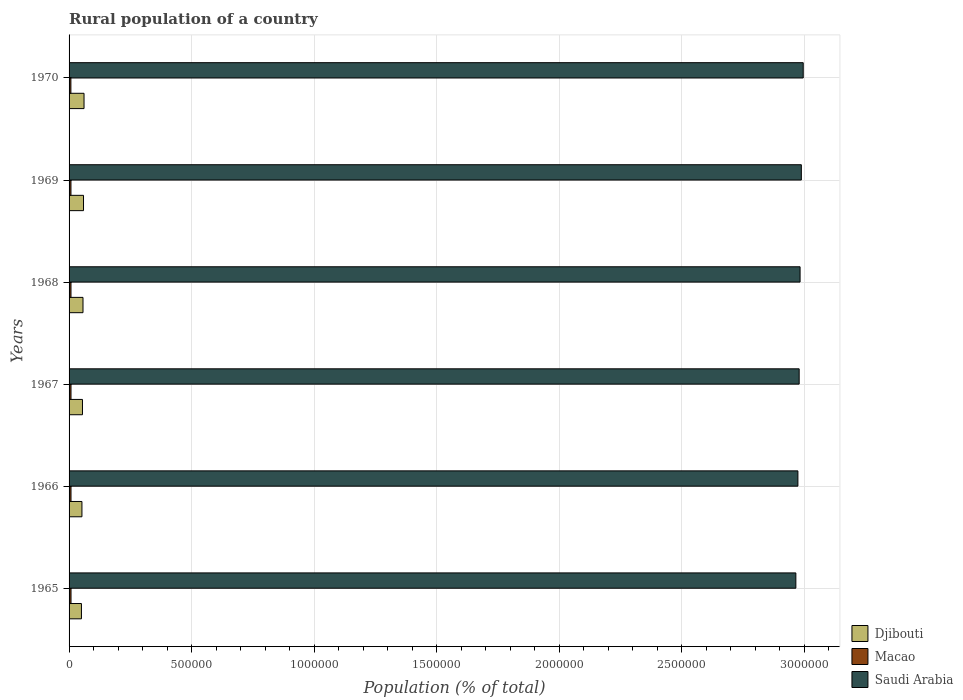How many different coloured bars are there?
Keep it short and to the point. 3. Are the number of bars per tick equal to the number of legend labels?
Keep it short and to the point. Yes. Are the number of bars on each tick of the Y-axis equal?
Make the answer very short. Yes. How many bars are there on the 4th tick from the top?
Give a very brief answer. 3. What is the label of the 4th group of bars from the top?
Give a very brief answer. 1967. What is the rural population in Djibouti in 1966?
Ensure brevity in your answer.  5.25e+04. Across all years, what is the maximum rural population in Saudi Arabia?
Your response must be concise. 3.00e+06. Across all years, what is the minimum rural population in Saudi Arabia?
Offer a very short reply. 2.97e+06. In which year was the rural population in Saudi Arabia minimum?
Keep it short and to the point. 1965. What is the total rural population in Macao in the graph?
Keep it short and to the point. 4.65e+04. What is the difference between the rural population in Djibouti in 1965 and that in 1968?
Your response must be concise. -6373. What is the difference between the rural population in Djibouti in 1966 and the rural population in Macao in 1968?
Offer a terse response. 4.47e+04. What is the average rural population in Macao per year?
Your answer should be compact. 7758. In the year 1965, what is the difference between the rural population in Saudi Arabia and rural population in Macao?
Your response must be concise. 2.96e+06. What is the ratio of the rural population in Saudi Arabia in 1966 to that in 1969?
Provide a succinct answer. 1. Is the rural population in Djibouti in 1965 less than that in 1970?
Your response must be concise. Yes. What is the difference between the highest and the second highest rural population in Saudi Arabia?
Your answer should be compact. 7679. What is the difference between the highest and the lowest rural population in Macao?
Provide a succinct answer. 460. In how many years, is the rural population in Macao greater than the average rural population in Macao taken over all years?
Provide a succinct answer. 4. What does the 1st bar from the top in 1969 represents?
Give a very brief answer. Saudi Arabia. What does the 2nd bar from the bottom in 1967 represents?
Provide a succinct answer. Macao. Are all the bars in the graph horizontal?
Provide a succinct answer. Yes. What is the difference between two consecutive major ticks on the X-axis?
Make the answer very short. 5.00e+05. How are the legend labels stacked?
Your answer should be very brief. Vertical. What is the title of the graph?
Offer a very short reply. Rural population of a country. Does "Sint Maarten (Dutch part)" appear as one of the legend labels in the graph?
Your answer should be compact. No. What is the label or title of the X-axis?
Provide a short and direct response. Population (% of total). What is the label or title of the Y-axis?
Give a very brief answer. Years. What is the Population (% of total) of Djibouti in 1965?
Offer a terse response. 5.05e+04. What is the Population (% of total) in Macao in 1965?
Your response must be concise. 7910. What is the Population (% of total) in Saudi Arabia in 1965?
Ensure brevity in your answer.  2.97e+06. What is the Population (% of total) of Djibouti in 1966?
Give a very brief answer. 5.25e+04. What is the Population (% of total) in Macao in 1966?
Make the answer very short. 7883. What is the Population (% of total) in Saudi Arabia in 1966?
Your answer should be compact. 2.97e+06. What is the Population (% of total) of Djibouti in 1967?
Make the answer very short. 5.47e+04. What is the Population (% of total) in Macao in 1967?
Provide a succinct answer. 7854. What is the Population (% of total) in Saudi Arabia in 1967?
Your response must be concise. 2.98e+06. What is the Population (% of total) in Djibouti in 1968?
Ensure brevity in your answer.  5.68e+04. What is the Population (% of total) in Macao in 1968?
Provide a short and direct response. 7790. What is the Population (% of total) of Saudi Arabia in 1968?
Keep it short and to the point. 2.98e+06. What is the Population (% of total) of Djibouti in 1969?
Give a very brief answer. 5.90e+04. What is the Population (% of total) in Macao in 1969?
Your answer should be compact. 7661. What is the Population (% of total) in Saudi Arabia in 1969?
Ensure brevity in your answer.  2.99e+06. What is the Population (% of total) of Djibouti in 1970?
Make the answer very short. 6.10e+04. What is the Population (% of total) in Macao in 1970?
Your answer should be very brief. 7450. What is the Population (% of total) in Saudi Arabia in 1970?
Provide a short and direct response. 3.00e+06. Across all years, what is the maximum Population (% of total) in Djibouti?
Ensure brevity in your answer.  6.10e+04. Across all years, what is the maximum Population (% of total) in Macao?
Offer a very short reply. 7910. Across all years, what is the maximum Population (% of total) of Saudi Arabia?
Provide a short and direct response. 3.00e+06. Across all years, what is the minimum Population (% of total) of Djibouti?
Make the answer very short. 5.05e+04. Across all years, what is the minimum Population (% of total) in Macao?
Ensure brevity in your answer.  7450. Across all years, what is the minimum Population (% of total) of Saudi Arabia?
Make the answer very short. 2.97e+06. What is the total Population (% of total) in Djibouti in the graph?
Provide a succinct answer. 3.34e+05. What is the total Population (% of total) in Macao in the graph?
Keep it short and to the point. 4.65e+04. What is the total Population (% of total) in Saudi Arabia in the graph?
Ensure brevity in your answer.  1.79e+07. What is the difference between the Population (% of total) in Djibouti in 1965 and that in 1966?
Offer a terse response. -2056. What is the difference between the Population (% of total) in Macao in 1965 and that in 1966?
Ensure brevity in your answer.  27. What is the difference between the Population (% of total) in Saudi Arabia in 1965 and that in 1966?
Provide a short and direct response. -8387. What is the difference between the Population (% of total) of Djibouti in 1965 and that in 1967?
Your response must be concise. -4200. What is the difference between the Population (% of total) in Saudi Arabia in 1965 and that in 1967?
Ensure brevity in your answer.  -1.35e+04. What is the difference between the Population (% of total) of Djibouti in 1965 and that in 1968?
Give a very brief answer. -6373. What is the difference between the Population (% of total) of Macao in 1965 and that in 1968?
Your answer should be very brief. 120. What is the difference between the Population (% of total) of Saudi Arabia in 1965 and that in 1968?
Make the answer very short. -1.73e+04. What is the difference between the Population (% of total) of Djibouti in 1965 and that in 1969?
Offer a very short reply. -8503. What is the difference between the Population (% of total) of Macao in 1965 and that in 1969?
Offer a terse response. 249. What is the difference between the Population (% of total) in Saudi Arabia in 1965 and that in 1969?
Provide a short and direct response. -2.24e+04. What is the difference between the Population (% of total) in Djibouti in 1965 and that in 1970?
Offer a terse response. -1.06e+04. What is the difference between the Population (% of total) in Macao in 1965 and that in 1970?
Your answer should be very brief. 460. What is the difference between the Population (% of total) in Saudi Arabia in 1965 and that in 1970?
Provide a short and direct response. -3.01e+04. What is the difference between the Population (% of total) in Djibouti in 1966 and that in 1967?
Provide a short and direct response. -2144. What is the difference between the Population (% of total) in Saudi Arabia in 1966 and that in 1967?
Your answer should be compact. -5134. What is the difference between the Population (% of total) of Djibouti in 1966 and that in 1968?
Give a very brief answer. -4317. What is the difference between the Population (% of total) of Macao in 1966 and that in 1968?
Your answer should be compact. 93. What is the difference between the Population (% of total) of Saudi Arabia in 1966 and that in 1968?
Keep it short and to the point. -8872. What is the difference between the Population (% of total) in Djibouti in 1966 and that in 1969?
Provide a short and direct response. -6447. What is the difference between the Population (% of total) in Macao in 1966 and that in 1969?
Make the answer very short. 222. What is the difference between the Population (% of total) of Saudi Arabia in 1966 and that in 1969?
Offer a terse response. -1.40e+04. What is the difference between the Population (% of total) in Djibouti in 1966 and that in 1970?
Offer a terse response. -8516. What is the difference between the Population (% of total) of Macao in 1966 and that in 1970?
Give a very brief answer. 433. What is the difference between the Population (% of total) of Saudi Arabia in 1966 and that in 1970?
Keep it short and to the point. -2.17e+04. What is the difference between the Population (% of total) in Djibouti in 1967 and that in 1968?
Offer a very short reply. -2173. What is the difference between the Population (% of total) of Saudi Arabia in 1967 and that in 1968?
Make the answer very short. -3738. What is the difference between the Population (% of total) of Djibouti in 1967 and that in 1969?
Offer a terse response. -4303. What is the difference between the Population (% of total) in Macao in 1967 and that in 1969?
Your answer should be compact. 193. What is the difference between the Population (% of total) in Saudi Arabia in 1967 and that in 1969?
Offer a terse response. -8873. What is the difference between the Population (% of total) in Djibouti in 1967 and that in 1970?
Offer a very short reply. -6372. What is the difference between the Population (% of total) of Macao in 1967 and that in 1970?
Offer a terse response. 404. What is the difference between the Population (% of total) in Saudi Arabia in 1967 and that in 1970?
Offer a very short reply. -1.66e+04. What is the difference between the Population (% of total) of Djibouti in 1968 and that in 1969?
Offer a terse response. -2130. What is the difference between the Population (% of total) of Macao in 1968 and that in 1969?
Provide a short and direct response. 129. What is the difference between the Population (% of total) in Saudi Arabia in 1968 and that in 1969?
Give a very brief answer. -5135. What is the difference between the Population (% of total) in Djibouti in 1968 and that in 1970?
Offer a terse response. -4199. What is the difference between the Population (% of total) of Macao in 1968 and that in 1970?
Your answer should be compact. 340. What is the difference between the Population (% of total) of Saudi Arabia in 1968 and that in 1970?
Ensure brevity in your answer.  -1.28e+04. What is the difference between the Population (% of total) of Djibouti in 1969 and that in 1970?
Keep it short and to the point. -2069. What is the difference between the Population (% of total) in Macao in 1969 and that in 1970?
Make the answer very short. 211. What is the difference between the Population (% of total) in Saudi Arabia in 1969 and that in 1970?
Provide a succinct answer. -7679. What is the difference between the Population (% of total) of Djibouti in 1965 and the Population (% of total) of Macao in 1966?
Provide a succinct answer. 4.26e+04. What is the difference between the Population (% of total) of Djibouti in 1965 and the Population (% of total) of Saudi Arabia in 1966?
Your answer should be very brief. -2.92e+06. What is the difference between the Population (% of total) in Macao in 1965 and the Population (% of total) in Saudi Arabia in 1966?
Offer a terse response. -2.97e+06. What is the difference between the Population (% of total) of Djibouti in 1965 and the Population (% of total) of Macao in 1967?
Give a very brief answer. 4.26e+04. What is the difference between the Population (% of total) of Djibouti in 1965 and the Population (% of total) of Saudi Arabia in 1967?
Your answer should be compact. -2.93e+06. What is the difference between the Population (% of total) of Macao in 1965 and the Population (% of total) of Saudi Arabia in 1967?
Ensure brevity in your answer.  -2.97e+06. What is the difference between the Population (% of total) in Djibouti in 1965 and the Population (% of total) in Macao in 1968?
Offer a terse response. 4.27e+04. What is the difference between the Population (% of total) in Djibouti in 1965 and the Population (% of total) in Saudi Arabia in 1968?
Provide a succinct answer. -2.93e+06. What is the difference between the Population (% of total) of Macao in 1965 and the Population (% of total) of Saudi Arabia in 1968?
Provide a succinct answer. -2.98e+06. What is the difference between the Population (% of total) of Djibouti in 1965 and the Population (% of total) of Macao in 1969?
Your answer should be very brief. 4.28e+04. What is the difference between the Population (% of total) in Djibouti in 1965 and the Population (% of total) in Saudi Arabia in 1969?
Ensure brevity in your answer.  -2.94e+06. What is the difference between the Population (% of total) in Macao in 1965 and the Population (% of total) in Saudi Arabia in 1969?
Keep it short and to the point. -2.98e+06. What is the difference between the Population (% of total) in Djibouti in 1965 and the Population (% of total) in Macao in 1970?
Provide a short and direct response. 4.30e+04. What is the difference between the Population (% of total) in Djibouti in 1965 and the Population (% of total) in Saudi Arabia in 1970?
Give a very brief answer. -2.95e+06. What is the difference between the Population (% of total) in Macao in 1965 and the Population (% of total) in Saudi Arabia in 1970?
Provide a short and direct response. -2.99e+06. What is the difference between the Population (% of total) in Djibouti in 1966 and the Population (% of total) in Macao in 1967?
Provide a short and direct response. 4.47e+04. What is the difference between the Population (% of total) of Djibouti in 1966 and the Population (% of total) of Saudi Arabia in 1967?
Offer a terse response. -2.93e+06. What is the difference between the Population (% of total) of Macao in 1966 and the Population (% of total) of Saudi Arabia in 1967?
Provide a short and direct response. -2.97e+06. What is the difference between the Population (% of total) of Djibouti in 1966 and the Population (% of total) of Macao in 1968?
Provide a succinct answer. 4.47e+04. What is the difference between the Population (% of total) of Djibouti in 1966 and the Population (% of total) of Saudi Arabia in 1968?
Offer a very short reply. -2.93e+06. What is the difference between the Population (% of total) in Macao in 1966 and the Population (% of total) in Saudi Arabia in 1968?
Offer a terse response. -2.98e+06. What is the difference between the Population (% of total) of Djibouti in 1966 and the Population (% of total) of Macao in 1969?
Offer a terse response. 4.49e+04. What is the difference between the Population (% of total) of Djibouti in 1966 and the Population (% of total) of Saudi Arabia in 1969?
Provide a succinct answer. -2.94e+06. What is the difference between the Population (% of total) of Macao in 1966 and the Population (% of total) of Saudi Arabia in 1969?
Offer a very short reply. -2.98e+06. What is the difference between the Population (% of total) of Djibouti in 1966 and the Population (% of total) of Macao in 1970?
Give a very brief answer. 4.51e+04. What is the difference between the Population (% of total) of Djibouti in 1966 and the Population (% of total) of Saudi Arabia in 1970?
Provide a short and direct response. -2.94e+06. What is the difference between the Population (% of total) of Macao in 1966 and the Population (% of total) of Saudi Arabia in 1970?
Provide a short and direct response. -2.99e+06. What is the difference between the Population (% of total) in Djibouti in 1967 and the Population (% of total) in Macao in 1968?
Provide a short and direct response. 4.69e+04. What is the difference between the Population (% of total) in Djibouti in 1967 and the Population (% of total) in Saudi Arabia in 1968?
Your answer should be very brief. -2.93e+06. What is the difference between the Population (% of total) of Macao in 1967 and the Population (% of total) of Saudi Arabia in 1968?
Your answer should be compact. -2.98e+06. What is the difference between the Population (% of total) in Djibouti in 1967 and the Population (% of total) in Macao in 1969?
Make the answer very short. 4.70e+04. What is the difference between the Population (% of total) in Djibouti in 1967 and the Population (% of total) in Saudi Arabia in 1969?
Keep it short and to the point. -2.93e+06. What is the difference between the Population (% of total) of Macao in 1967 and the Population (% of total) of Saudi Arabia in 1969?
Ensure brevity in your answer.  -2.98e+06. What is the difference between the Population (% of total) in Djibouti in 1967 and the Population (% of total) in Macao in 1970?
Offer a terse response. 4.72e+04. What is the difference between the Population (% of total) of Djibouti in 1967 and the Population (% of total) of Saudi Arabia in 1970?
Offer a very short reply. -2.94e+06. What is the difference between the Population (% of total) in Macao in 1967 and the Population (% of total) in Saudi Arabia in 1970?
Offer a very short reply. -2.99e+06. What is the difference between the Population (% of total) of Djibouti in 1968 and the Population (% of total) of Macao in 1969?
Offer a terse response. 4.92e+04. What is the difference between the Population (% of total) of Djibouti in 1968 and the Population (% of total) of Saudi Arabia in 1969?
Offer a terse response. -2.93e+06. What is the difference between the Population (% of total) of Macao in 1968 and the Population (% of total) of Saudi Arabia in 1969?
Keep it short and to the point. -2.98e+06. What is the difference between the Population (% of total) of Djibouti in 1968 and the Population (% of total) of Macao in 1970?
Your answer should be compact. 4.94e+04. What is the difference between the Population (% of total) in Djibouti in 1968 and the Population (% of total) in Saudi Arabia in 1970?
Provide a succinct answer. -2.94e+06. What is the difference between the Population (% of total) in Macao in 1968 and the Population (% of total) in Saudi Arabia in 1970?
Keep it short and to the point. -2.99e+06. What is the difference between the Population (% of total) of Djibouti in 1969 and the Population (% of total) of Macao in 1970?
Offer a very short reply. 5.15e+04. What is the difference between the Population (% of total) in Djibouti in 1969 and the Population (% of total) in Saudi Arabia in 1970?
Give a very brief answer. -2.94e+06. What is the difference between the Population (% of total) in Macao in 1969 and the Population (% of total) in Saudi Arabia in 1970?
Keep it short and to the point. -2.99e+06. What is the average Population (% of total) of Djibouti per year?
Provide a succinct answer. 5.57e+04. What is the average Population (% of total) of Macao per year?
Your answer should be very brief. 7758. What is the average Population (% of total) in Saudi Arabia per year?
Give a very brief answer. 2.98e+06. In the year 1965, what is the difference between the Population (% of total) in Djibouti and Population (% of total) in Macao?
Your answer should be very brief. 4.25e+04. In the year 1965, what is the difference between the Population (% of total) of Djibouti and Population (% of total) of Saudi Arabia?
Make the answer very short. -2.92e+06. In the year 1965, what is the difference between the Population (% of total) in Macao and Population (% of total) in Saudi Arabia?
Offer a very short reply. -2.96e+06. In the year 1966, what is the difference between the Population (% of total) of Djibouti and Population (% of total) of Macao?
Make the answer very short. 4.46e+04. In the year 1966, what is the difference between the Population (% of total) in Djibouti and Population (% of total) in Saudi Arabia?
Offer a very short reply. -2.92e+06. In the year 1966, what is the difference between the Population (% of total) of Macao and Population (% of total) of Saudi Arabia?
Offer a very short reply. -2.97e+06. In the year 1967, what is the difference between the Population (% of total) in Djibouti and Population (% of total) in Macao?
Your answer should be compact. 4.68e+04. In the year 1967, what is the difference between the Population (% of total) of Djibouti and Population (% of total) of Saudi Arabia?
Offer a very short reply. -2.92e+06. In the year 1967, what is the difference between the Population (% of total) in Macao and Population (% of total) in Saudi Arabia?
Your response must be concise. -2.97e+06. In the year 1968, what is the difference between the Population (% of total) of Djibouti and Population (% of total) of Macao?
Your response must be concise. 4.90e+04. In the year 1968, what is the difference between the Population (% of total) of Djibouti and Population (% of total) of Saudi Arabia?
Your answer should be compact. -2.93e+06. In the year 1968, what is the difference between the Population (% of total) of Macao and Population (% of total) of Saudi Arabia?
Your answer should be compact. -2.98e+06. In the year 1969, what is the difference between the Population (% of total) in Djibouti and Population (% of total) in Macao?
Your answer should be very brief. 5.13e+04. In the year 1969, what is the difference between the Population (% of total) of Djibouti and Population (% of total) of Saudi Arabia?
Make the answer very short. -2.93e+06. In the year 1969, what is the difference between the Population (% of total) of Macao and Population (% of total) of Saudi Arabia?
Ensure brevity in your answer.  -2.98e+06. In the year 1970, what is the difference between the Population (% of total) of Djibouti and Population (% of total) of Macao?
Your response must be concise. 5.36e+04. In the year 1970, what is the difference between the Population (% of total) of Djibouti and Population (% of total) of Saudi Arabia?
Offer a very short reply. -2.93e+06. In the year 1970, what is the difference between the Population (% of total) in Macao and Population (% of total) in Saudi Arabia?
Your answer should be very brief. -2.99e+06. What is the ratio of the Population (% of total) of Djibouti in 1965 to that in 1966?
Keep it short and to the point. 0.96. What is the ratio of the Population (% of total) in Saudi Arabia in 1965 to that in 1966?
Give a very brief answer. 1. What is the ratio of the Population (% of total) of Djibouti in 1965 to that in 1967?
Your answer should be compact. 0.92. What is the ratio of the Population (% of total) of Macao in 1965 to that in 1967?
Give a very brief answer. 1.01. What is the ratio of the Population (% of total) in Djibouti in 1965 to that in 1968?
Your answer should be compact. 0.89. What is the ratio of the Population (% of total) of Macao in 1965 to that in 1968?
Your answer should be compact. 1.02. What is the ratio of the Population (% of total) in Djibouti in 1965 to that in 1969?
Offer a terse response. 0.86. What is the ratio of the Population (% of total) in Macao in 1965 to that in 1969?
Offer a very short reply. 1.03. What is the ratio of the Population (% of total) in Saudi Arabia in 1965 to that in 1969?
Your response must be concise. 0.99. What is the ratio of the Population (% of total) in Djibouti in 1965 to that in 1970?
Provide a short and direct response. 0.83. What is the ratio of the Population (% of total) in Macao in 1965 to that in 1970?
Your answer should be very brief. 1.06. What is the ratio of the Population (% of total) in Djibouti in 1966 to that in 1967?
Provide a succinct answer. 0.96. What is the ratio of the Population (% of total) in Macao in 1966 to that in 1967?
Ensure brevity in your answer.  1. What is the ratio of the Population (% of total) in Djibouti in 1966 to that in 1968?
Provide a short and direct response. 0.92. What is the ratio of the Population (% of total) in Macao in 1966 to that in 1968?
Your answer should be very brief. 1.01. What is the ratio of the Population (% of total) in Saudi Arabia in 1966 to that in 1968?
Offer a very short reply. 1. What is the ratio of the Population (% of total) of Djibouti in 1966 to that in 1969?
Give a very brief answer. 0.89. What is the ratio of the Population (% of total) in Djibouti in 1966 to that in 1970?
Offer a very short reply. 0.86. What is the ratio of the Population (% of total) in Macao in 1966 to that in 1970?
Your response must be concise. 1.06. What is the ratio of the Population (% of total) in Djibouti in 1967 to that in 1968?
Give a very brief answer. 0.96. What is the ratio of the Population (% of total) in Macao in 1967 to that in 1968?
Your answer should be very brief. 1.01. What is the ratio of the Population (% of total) in Djibouti in 1967 to that in 1969?
Offer a terse response. 0.93. What is the ratio of the Population (% of total) of Macao in 1967 to that in 1969?
Your response must be concise. 1.03. What is the ratio of the Population (% of total) of Djibouti in 1967 to that in 1970?
Provide a short and direct response. 0.9. What is the ratio of the Population (% of total) in Macao in 1967 to that in 1970?
Provide a short and direct response. 1.05. What is the ratio of the Population (% of total) in Saudi Arabia in 1967 to that in 1970?
Keep it short and to the point. 0.99. What is the ratio of the Population (% of total) of Djibouti in 1968 to that in 1969?
Offer a terse response. 0.96. What is the ratio of the Population (% of total) of Macao in 1968 to that in 1969?
Offer a very short reply. 1.02. What is the ratio of the Population (% of total) in Djibouti in 1968 to that in 1970?
Provide a short and direct response. 0.93. What is the ratio of the Population (% of total) of Macao in 1968 to that in 1970?
Keep it short and to the point. 1.05. What is the ratio of the Population (% of total) of Djibouti in 1969 to that in 1970?
Make the answer very short. 0.97. What is the ratio of the Population (% of total) in Macao in 1969 to that in 1970?
Offer a terse response. 1.03. What is the difference between the highest and the second highest Population (% of total) of Djibouti?
Provide a succinct answer. 2069. What is the difference between the highest and the second highest Population (% of total) of Macao?
Provide a short and direct response. 27. What is the difference between the highest and the second highest Population (% of total) of Saudi Arabia?
Keep it short and to the point. 7679. What is the difference between the highest and the lowest Population (% of total) of Djibouti?
Your response must be concise. 1.06e+04. What is the difference between the highest and the lowest Population (% of total) of Macao?
Your answer should be very brief. 460. What is the difference between the highest and the lowest Population (% of total) of Saudi Arabia?
Offer a very short reply. 3.01e+04. 